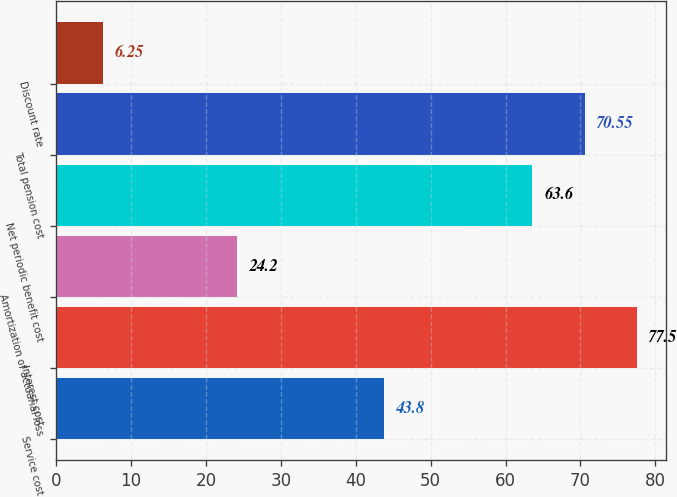Convert chart to OTSL. <chart><loc_0><loc_0><loc_500><loc_500><bar_chart><fcel>Service cost<fcel>Interest cost<fcel>Amortization of actuarial loss<fcel>Net periodic benefit cost<fcel>Total pension cost<fcel>Discount rate<nl><fcel>43.8<fcel>77.5<fcel>24.2<fcel>63.6<fcel>70.55<fcel>6.25<nl></chart> 